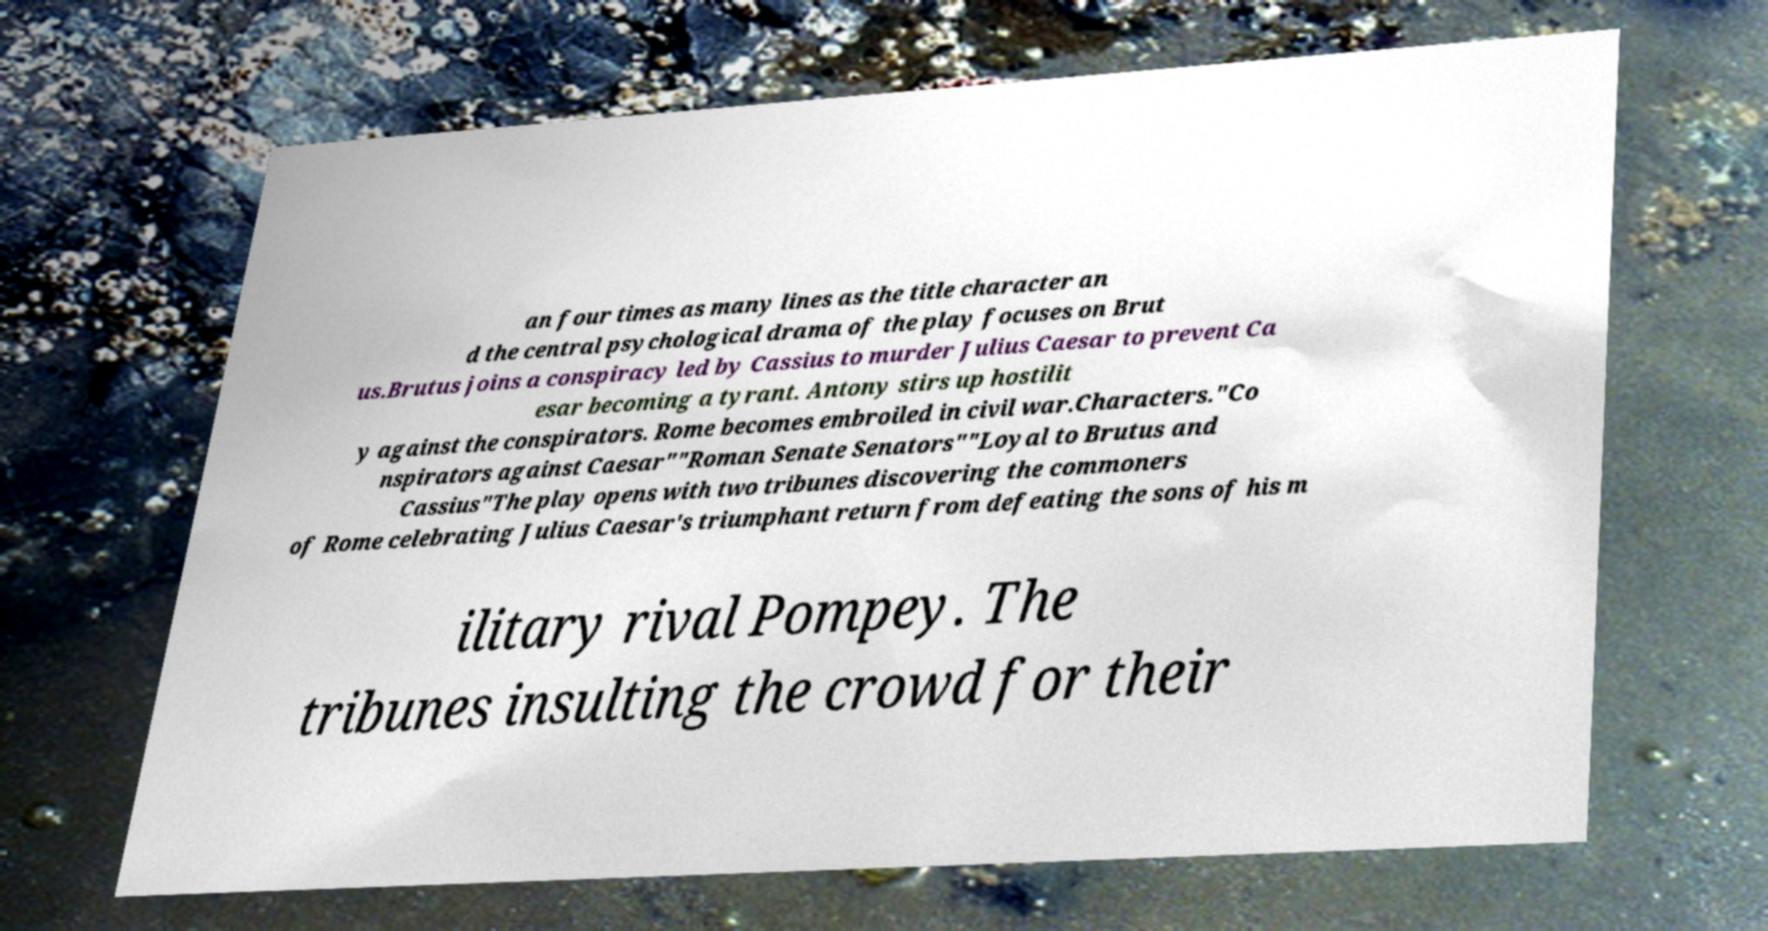What messages or text are displayed in this image? I need them in a readable, typed format. an four times as many lines as the title character an d the central psychological drama of the play focuses on Brut us.Brutus joins a conspiracy led by Cassius to murder Julius Caesar to prevent Ca esar becoming a tyrant. Antony stirs up hostilit y against the conspirators. Rome becomes embroiled in civil war.Characters."Co nspirators against Caesar""Roman Senate Senators""Loyal to Brutus and Cassius"The play opens with two tribunes discovering the commoners of Rome celebrating Julius Caesar's triumphant return from defeating the sons of his m ilitary rival Pompey. The tribunes insulting the crowd for their 